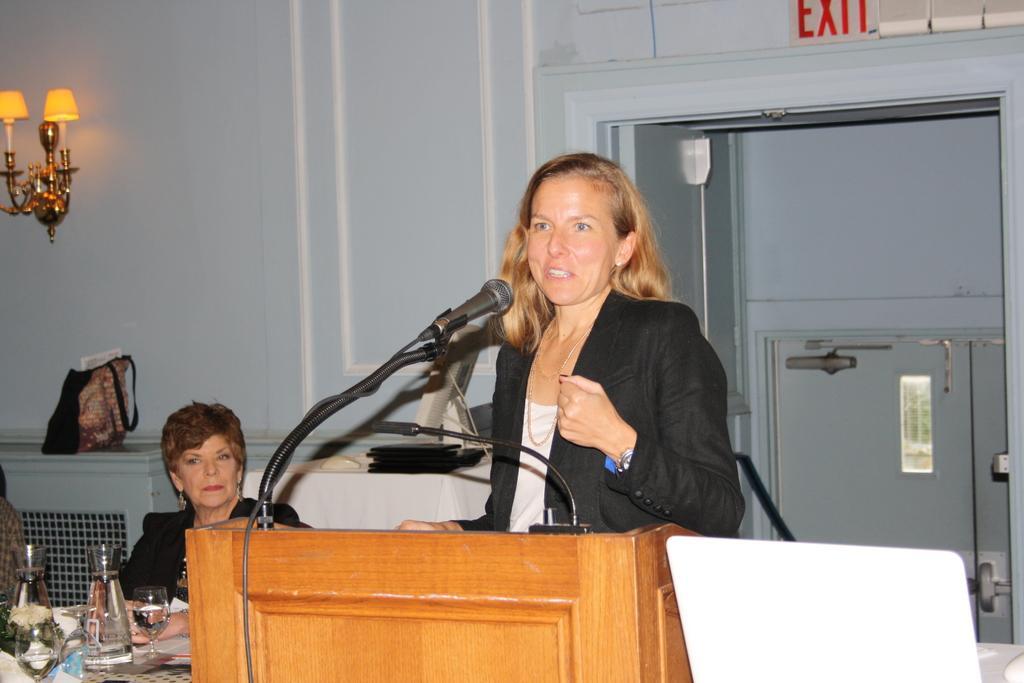How would you summarize this image in a sentence or two? In this image there is a woman speaking on the dais in front of a mic, beside the woman there is another woman sitting on a chair, in front of the woman on the table there are glasses and a few other objects, behind the woman there is a bag, in the background of the image there is a lamp on the wall and there is an exit door. 